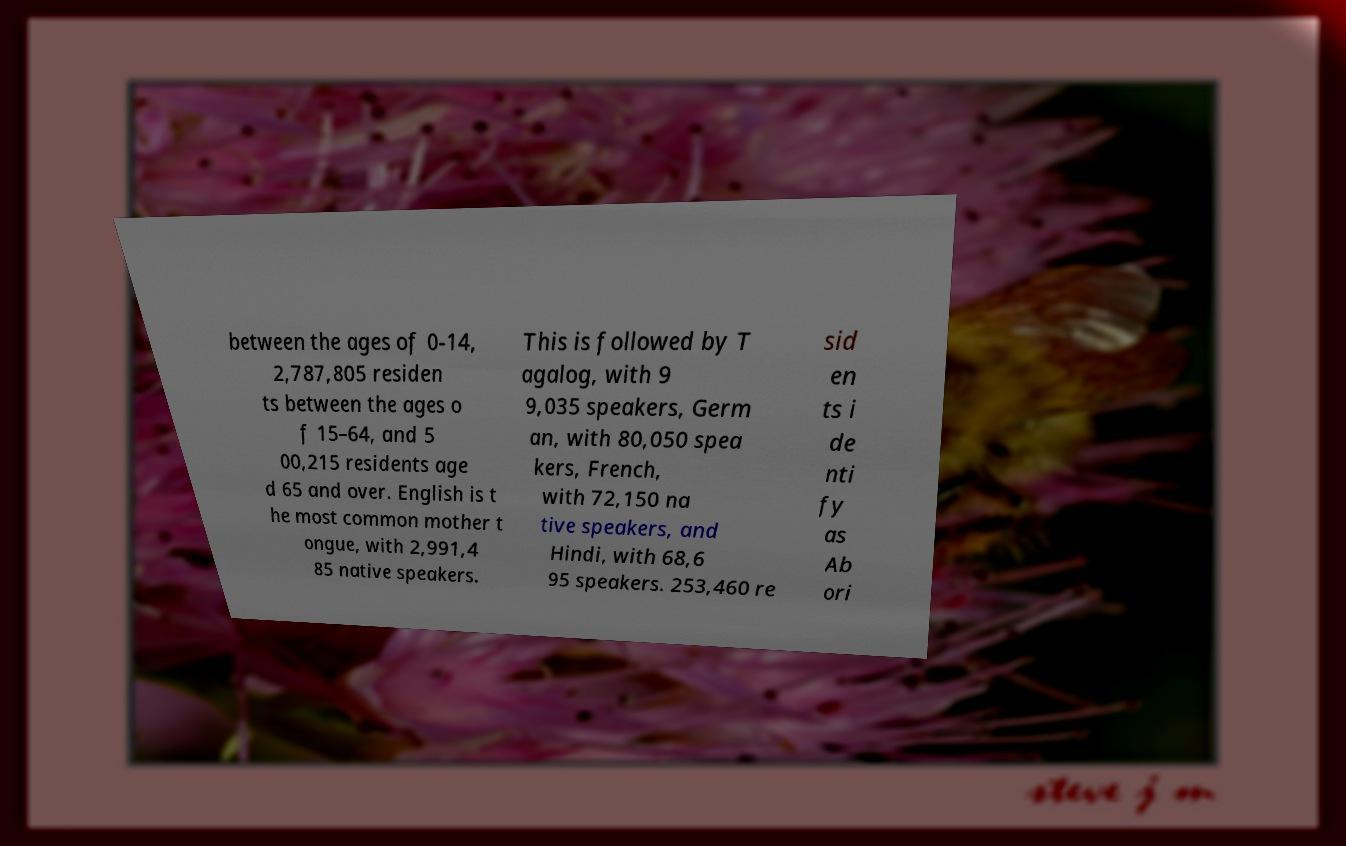Can you read and provide the text displayed in the image?This photo seems to have some interesting text. Can you extract and type it out for me? between the ages of 0-14, 2,787,805 residen ts between the ages o f 15–64, and 5 00,215 residents age d 65 and over. English is t he most common mother t ongue, with 2,991,4 85 native speakers. This is followed by T agalog, with 9 9,035 speakers, Germ an, with 80,050 spea kers, French, with 72,150 na tive speakers, and Hindi, with 68,6 95 speakers. 253,460 re sid en ts i de nti fy as Ab ori 